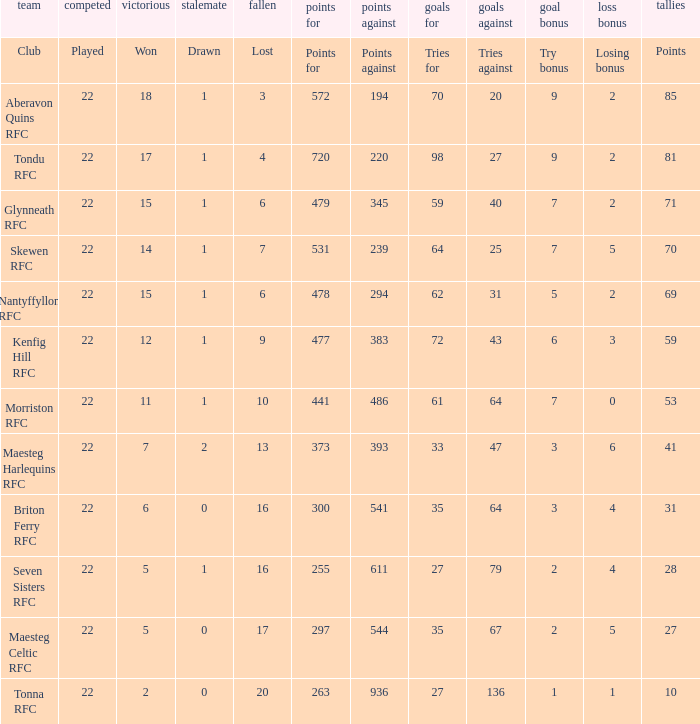What is the value of the points column when the value of the column lost is "lost" Points. 